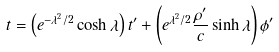Convert formula to latex. <formula><loc_0><loc_0><loc_500><loc_500>t = \left ( e ^ { - \lambda ^ { 2 } / 2 } \cosh { \lambda } \right ) t ^ { \prime } + \left ( e ^ { \lambda ^ { 2 } / 2 } \frac { \rho ^ { \prime } } { c } \sinh { \lambda } \right ) \phi ^ { \prime }</formula> 